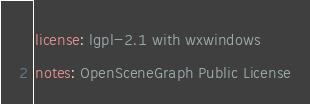<code> <loc_0><loc_0><loc_500><loc_500><_YAML_>license: lgpl-2.1 with wxwindows 
notes: OpenSceneGraph Public License
</code> 